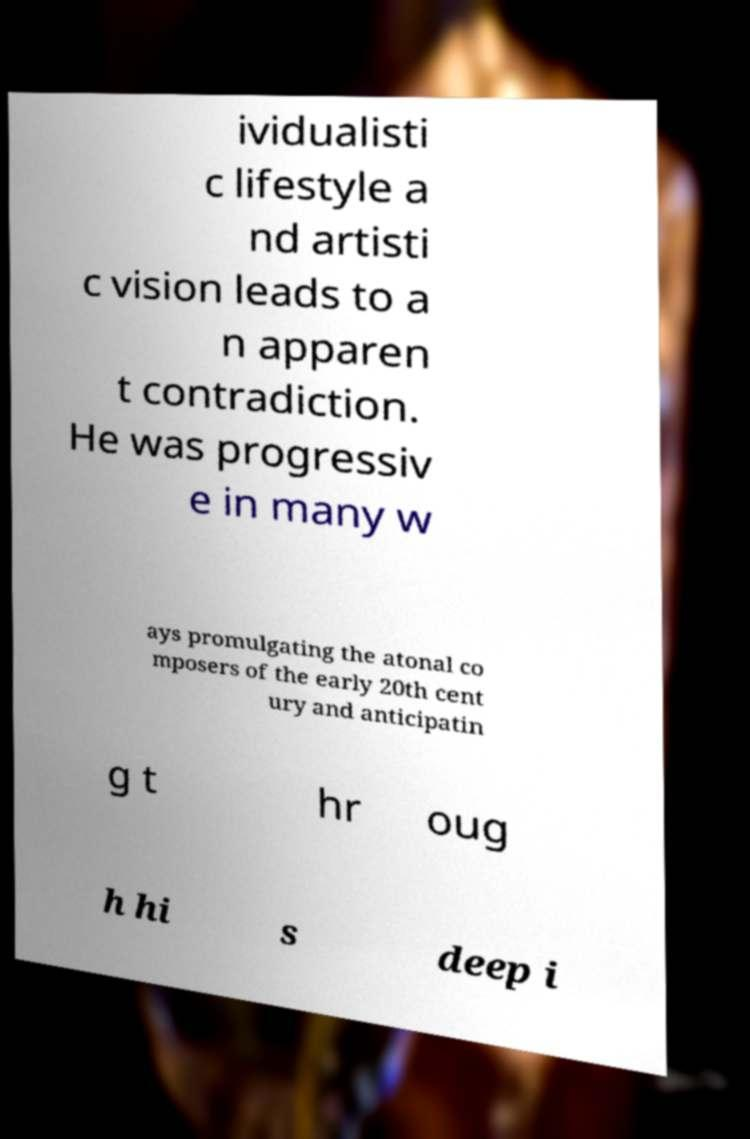Could you assist in decoding the text presented in this image and type it out clearly? ividualisti c lifestyle a nd artisti c vision leads to a n apparen t contradiction. He was progressiv e in many w ays promulgating the atonal co mposers of the early 20th cent ury and anticipatin g t hr oug h hi s deep i 